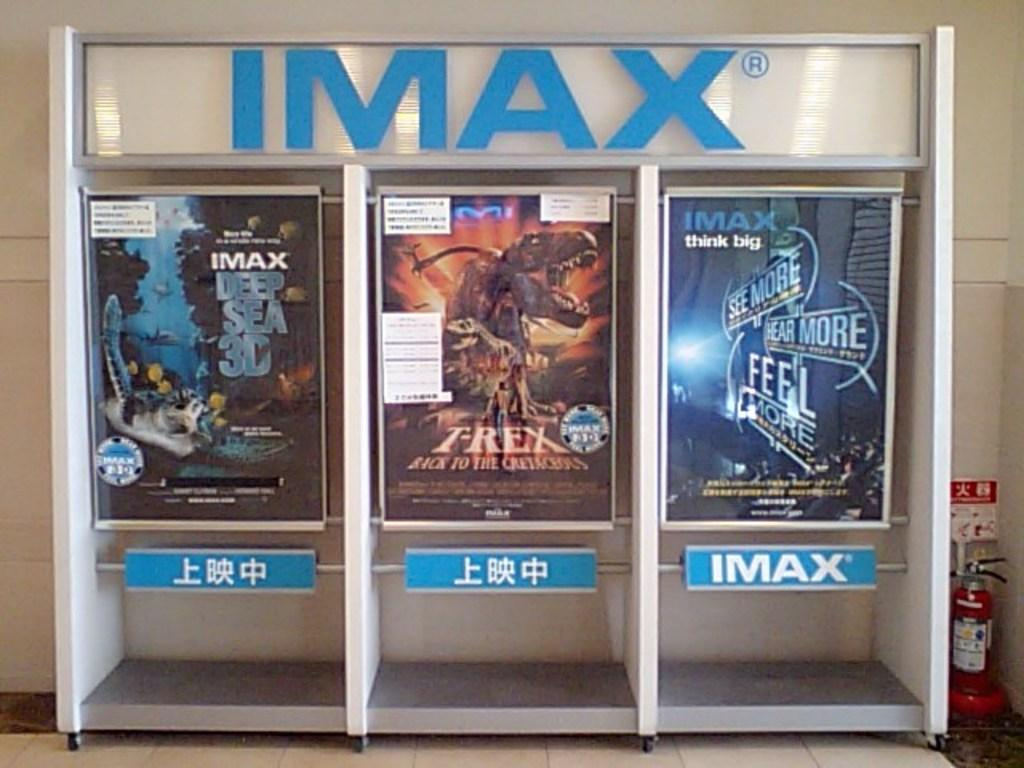<image>
Give a short and clear explanation of the subsequent image. three framed posters underneath a sign that says 'imax' on it 